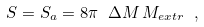Convert formula to latex. <formula><loc_0><loc_0><loc_500><loc_500>S = S _ { a } = 8 \pi \ \Delta M \, M _ { e x t r } \ ,</formula> 